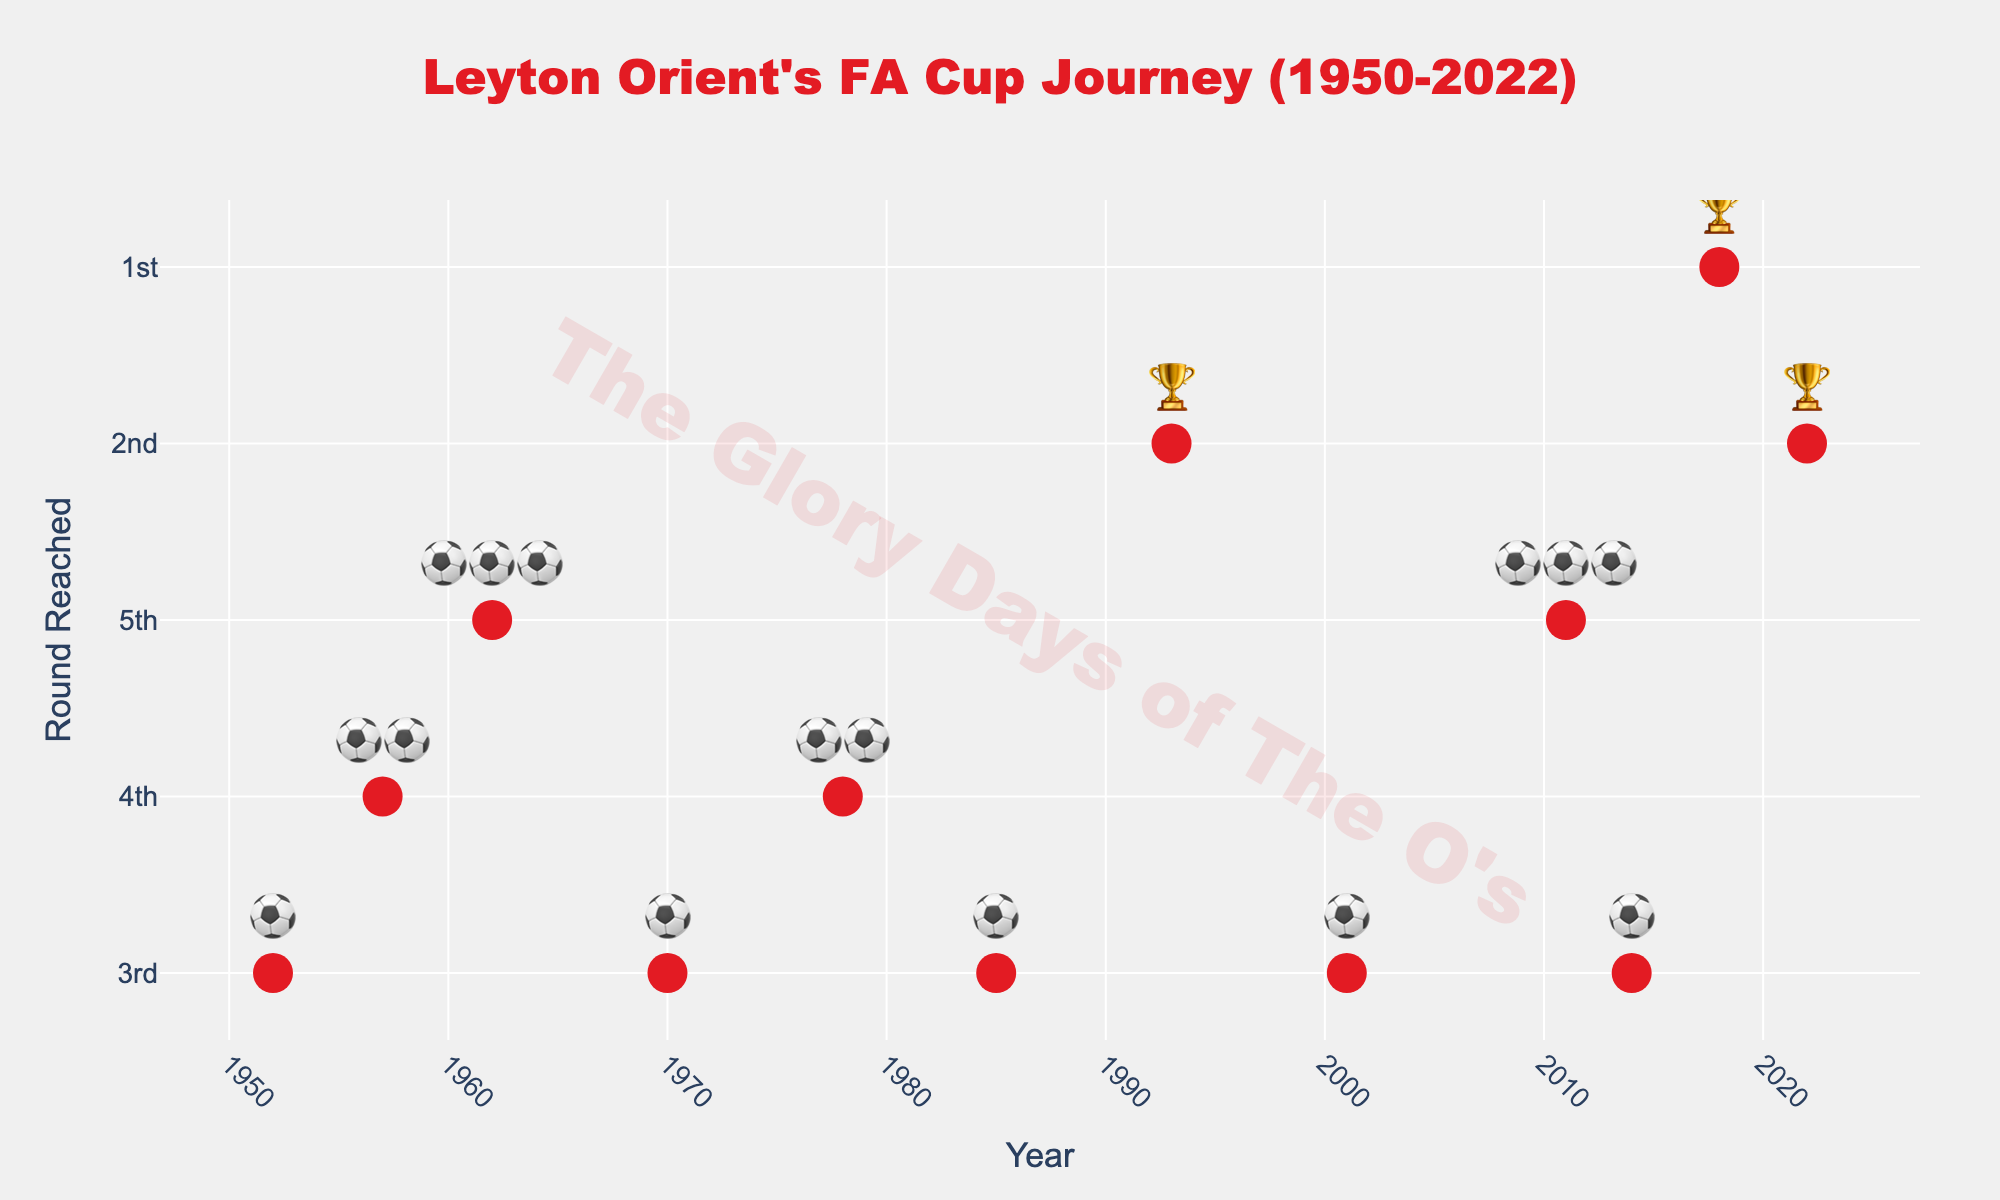How many different years are shown in the chart? Count the distinct data points on the x-axis, which represents different years of Leyton Orient's performances.
Answer: 12 Which year did Leyton Orient reach the Fifth Round the first time according to the chart? Find the earliest year on the x-axis with a fifth round marker, which is denoted by three football emojis (⚽⚽⚽).
Answer: 1962 What symbols represent the rounds Leyton Orient reached most frequently? Observe the emoji representations beside each data point and determine which one appears most often.
Answer: ⚽ How many times did Leyton Orient reach at least the Fourth Round? Count the number of markers with at least two football emojis (⚽⚽) or more.
Answer: 3 What is the longest gap between two consecutive appearances in the chart? Calculate the differences between consecutive years and identify the maximum gap.
Answer: 14 years Which year did Leyton Orient reach only the First Round? Look for the year with a single cup emoji (🏆).
Answer: 2018 How many times did Leyton Orient fail to go beyond the Second Round since 2000? Count the markers from 2000 onwards with either one or two cup emojis (🏆, 🏆🏆).
Answer: 2 What is the average number of rounds reached, represented in terms of emojis? Convert the emojis to their round equivalent and then calculate the average round.
Answer: 2.67 or close to third round (⚽) Compare the performances in the 1960s and the 2010s. Which decade had better results in terms of the highest round reached? Identify the highest emoji count for the 1960s and 2010s decades and compare. 1960s: ⚽⚽⚽ (1962); 2010s: ⚽⚽⚽ (2011).
Answer: Equal In which decade did Leyton Orient reach the Third Round most frequently? Count how many times they reached the Third Round (⚽) in each decade.
Answer: 2010s 